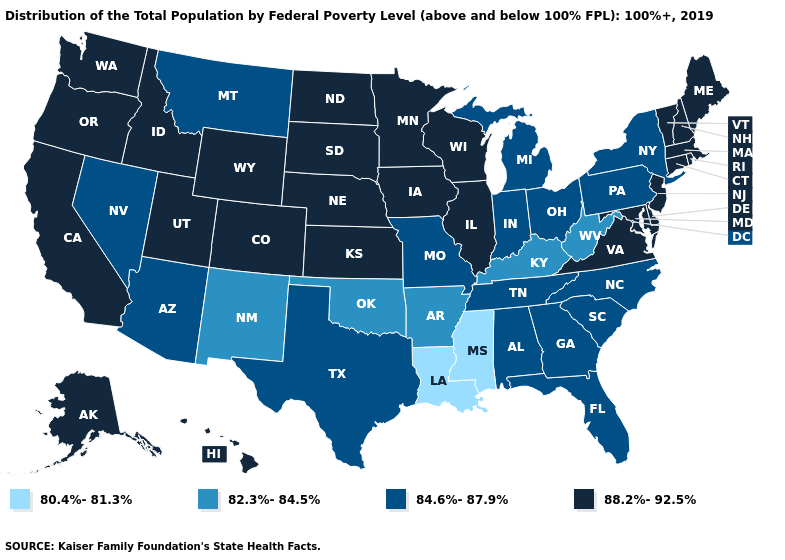Name the states that have a value in the range 88.2%-92.5%?
Keep it brief. Alaska, California, Colorado, Connecticut, Delaware, Hawaii, Idaho, Illinois, Iowa, Kansas, Maine, Maryland, Massachusetts, Minnesota, Nebraska, New Hampshire, New Jersey, North Dakota, Oregon, Rhode Island, South Dakota, Utah, Vermont, Virginia, Washington, Wisconsin, Wyoming. Does Pennsylvania have the highest value in the Northeast?
Quick response, please. No. What is the value of Tennessee?
Answer briefly. 84.6%-87.9%. What is the value of Missouri?
Answer briefly. 84.6%-87.9%. Does Louisiana have the lowest value in the South?
Answer briefly. Yes. Does Maryland have the highest value in the South?
Give a very brief answer. Yes. Name the states that have a value in the range 82.3%-84.5%?
Concise answer only. Arkansas, Kentucky, New Mexico, Oklahoma, West Virginia. Which states have the lowest value in the USA?
Keep it brief. Louisiana, Mississippi. Name the states that have a value in the range 80.4%-81.3%?
Keep it brief. Louisiana, Mississippi. Which states have the lowest value in the USA?
Write a very short answer. Louisiana, Mississippi. What is the lowest value in the South?
Give a very brief answer. 80.4%-81.3%. Which states have the lowest value in the USA?
Answer briefly. Louisiana, Mississippi. What is the value of Illinois?
Write a very short answer. 88.2%-92.5%. What is the highest value in the Northeast ?
Be succinct. 88.2%-92.5%. Does New York have the highest value in the Northeast?
Be succinct. No. 